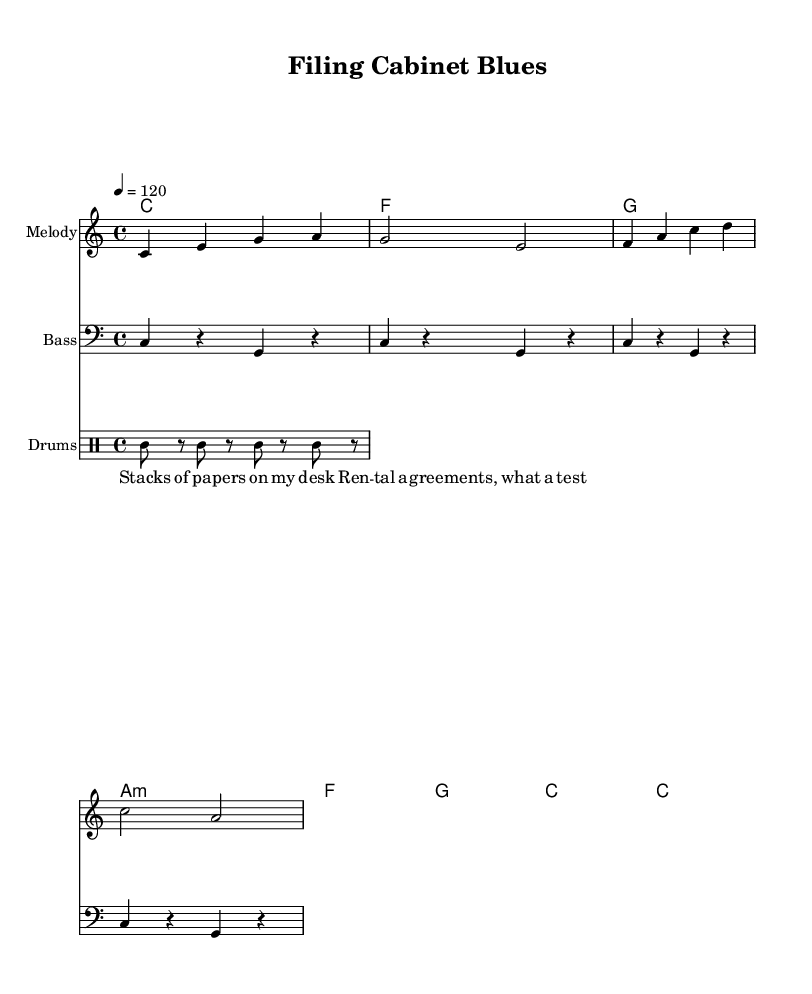What is the key signature of this music? The key signature indicated is C major, which is represented by no sharps or flats in the key signature.
Answer: C major What is the time signature of this piece? The time signature is specified as 4/4, which means there are four beats in each measure and the quarter note gets one beat.
Answer: 4/4 What is the tempo marking for this music? The tempo marking is set at 120 beats per minute, indicated by the number following the "tempo" instruction.
Answer: 120 How many measures are in the melody? The melody consists of four measures, which can be counted by looking at the measure lines in the sheet music.
Answer: 4 What is the name of the bass clef staff? The bass clef staff is labeled "Bass," which is a standard notation indicating that this staff plays lower-pitched notes.
Answer: Bass What type of chords are used in the harmony section? The harmony consists of triadic chords, including major and minor chords, as seen from the symbols in the chord names.
Answer: Triadic What phrase captures the theme of the lyrics? The lyrics encompass the theme of organization and struggle with paperwork, as summarized in the first few lines of the text.
Answer: Organizing papers 